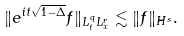<formula> <loc_0><loc_0><loc_500><loc_500>\| e ^ { i t \sqrt { 1 - \Delta } } f \| _ { L ^ { q } _ { t } L ^ { r } _ { x } } \lesssim \| f \| _ { H ^ { s } } .</formula> 